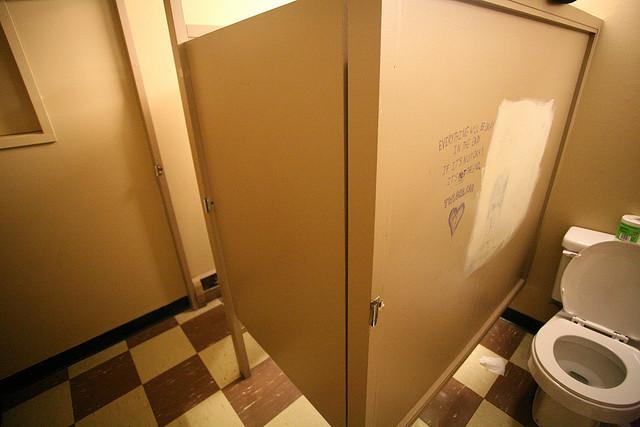How many toilets are in this bathroom?
Concise answer only. 2. Did someone write on the wall?
Concise answer only. Yes. Does the toilet need to be flushed?
Answer briefly. No. 